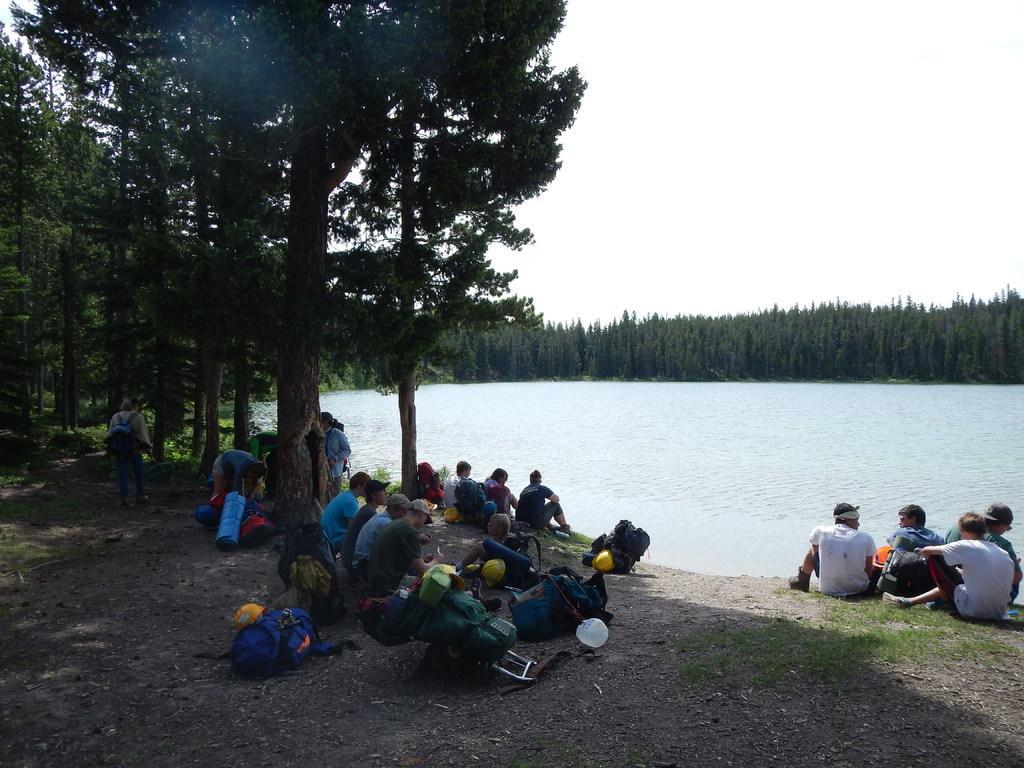Describe this image in one or two sentences. In this image there are group of people sitting , bags , helmets, water, trees, and in the background there is sky. 